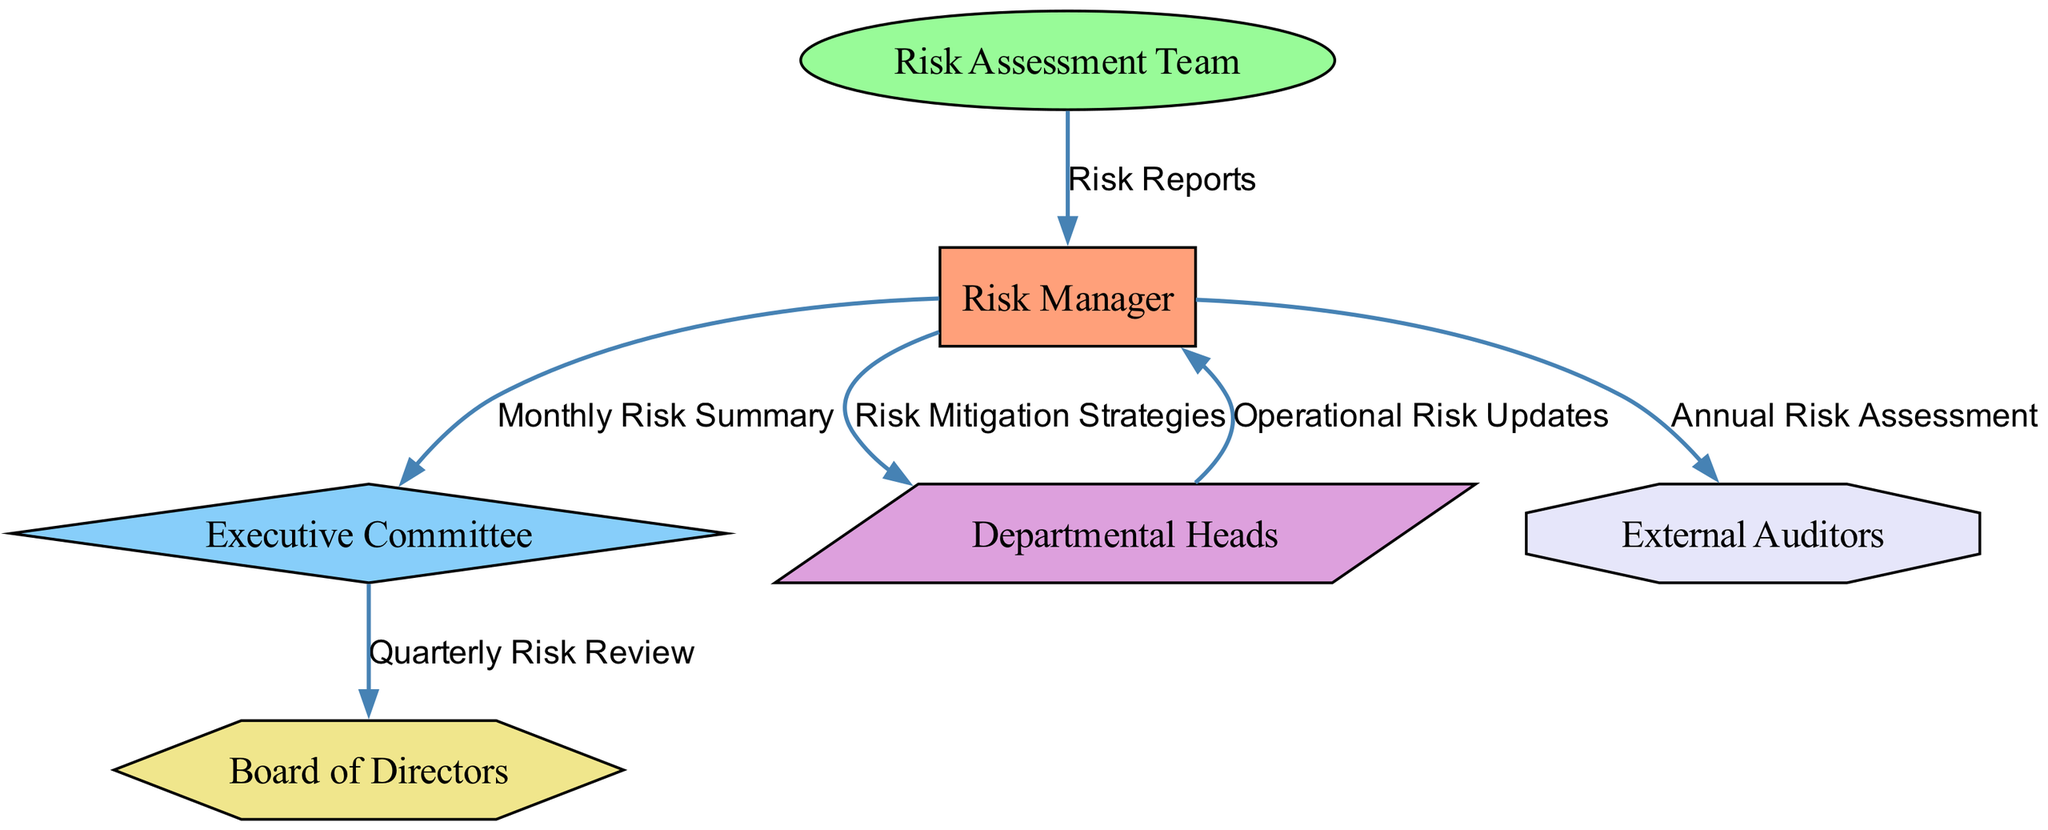What is the total number of nodes in the diagram? The diagram contains six distinct entities representing different roles in the risk reporting and escalation process. These are: Risk Manager, Risk Assessment Team, Executive Committee, Departmental Heads, Board of Directors, and External Auditors. Counting them provides the total number.
Answer: Six Who sends risk reports to the Risk Manager? The Risk Assessment Team is explicitly indicated as the source that provides Risk Reports directed to the Risk Manager. This is shown in the diagram by the edge connecting these two nodes with the corresponding label.
Answer: Risk Assessment Team What does the Executive Committee receive from the Risk Manager? The diagram indicates that the Executive Committee receives a Monthly Risk Summary from the Risk Manager. This is represented as a directed edge from the Risk Manager to the Executive Committee, labeled accordingly.
Answer: Monthly Risk Summary How many different types of documents are listed in the edges of the diagram? The diagram features five distinct labels for the edges connecting the nodes, each representing a type of document or report exchanged: Risk Reports, Monthly Risk Summary, Risk Mitigation Strategies, Quarterly Risk Review, and Annual Risk Assessment. By counting these unique labels, we arrive at the answer.
Answer: Five Which node has a bi-directional relationship with the Risk Manager? The Departmental Heads and the Risk Manager have a bi-directional relationship, as shown by the directed edges pointing both ways. This indicates that not only do the Departmental Heads send Operational Risk Updates to the Risk Manager, but they also receive Risk Mitigation Strategies from him.
Answer: Departmental Heads What is the purpose of the edge labeled "Quarterly Risk Review"? The Quarterly Risk Review connects the Executive Committee to the Board of Directors, suggesting that it serves to update the Board with insights and evaluations derived from quarterly risk assessments. This is inferred from the directionality of the edge and context provided by the roles of the connected nodes.
Answer: To update the Board of Directors How does the Risk Manager communicate the Annual Risk Assessment? The Risk Manager has a single directional edge that leads to External Auditors, conveying the Annual Risk Assessment. The diagram explicitly illustrates this one-way communication—indicating that the Risk Manager sends this assessment to the auditors for review or compliance purposes.
Answer: To External Auditors What color represents the Risk Assessment Team in the diagram? The Risk Assessment Team is represented in a greenish hue (Hex: #98FB98) as indicated in the diagram's color coding for nodes. The specific color choice helps delineate this role visually and associate it with their function in the information flow.
Answer: Light green What type of shape represents the Board of Directors? In the diagram, the Board of Directors is represented as a hexagon, which differentiates it visually from the other entities based on its shape. This distinctive shape is part of the custom node styles used in the diagram's visual representation.
Answer: Hexagon 